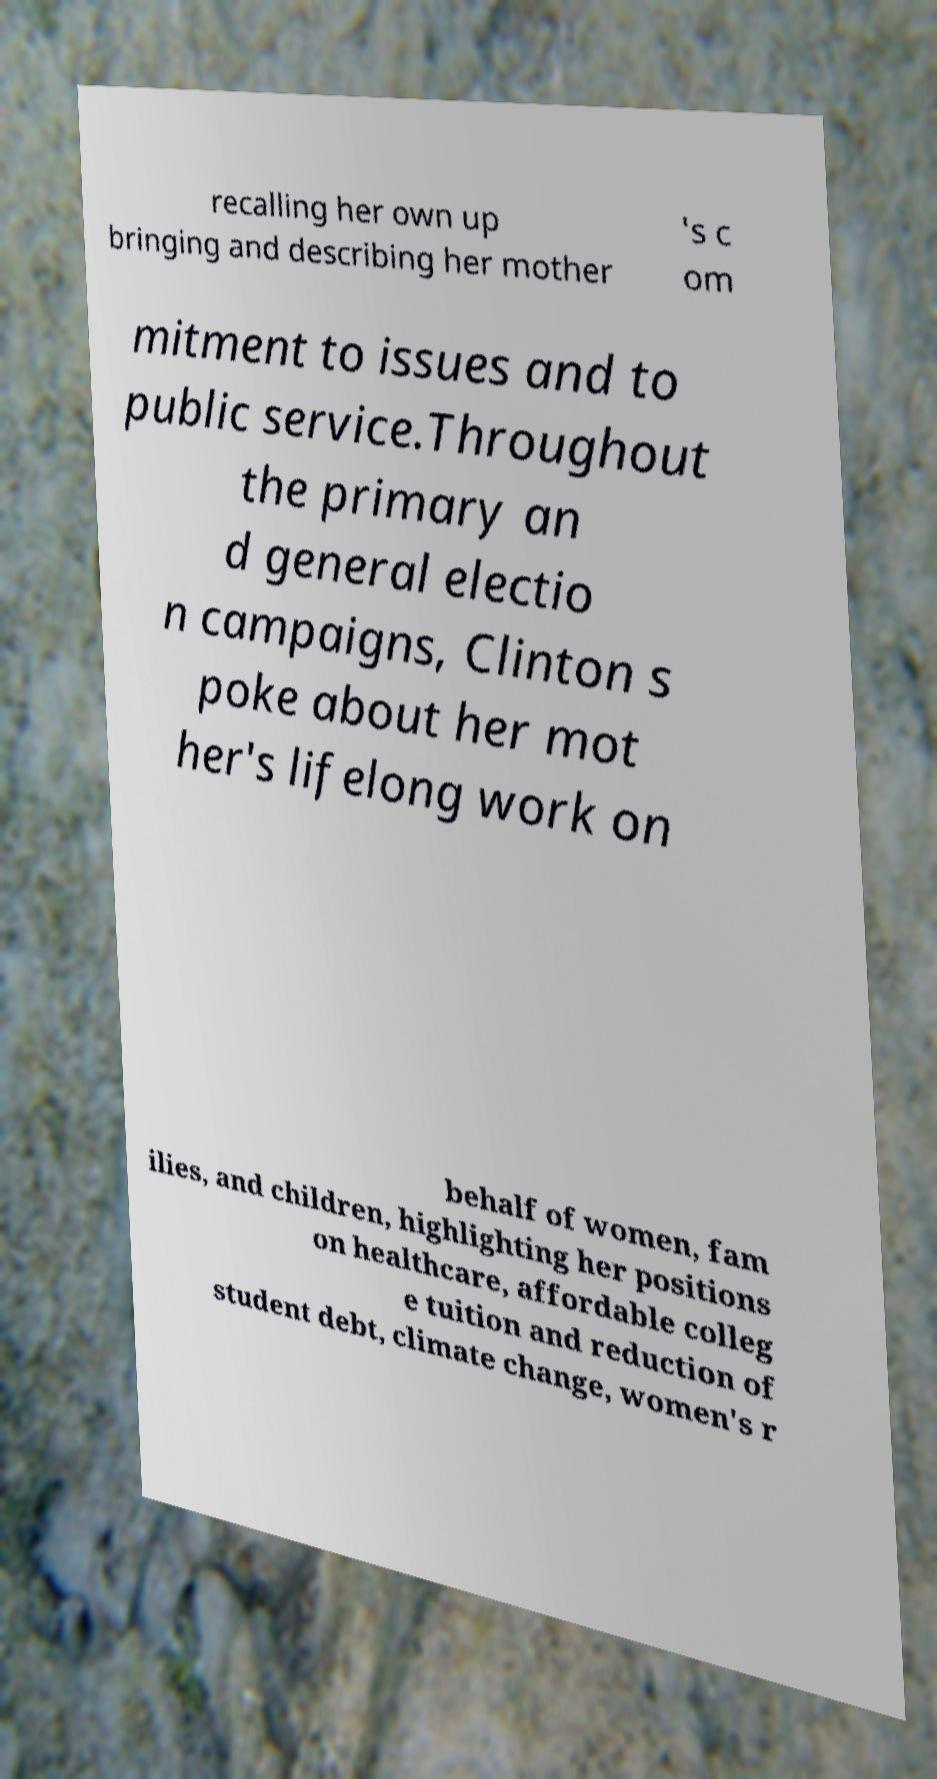Can you accurately transcribe the text from the provided image for me? recalling her own up bringing and describing her mother 's c om mitment to issues and to public service.Throughout the primary an d general electio n campaigns, Clinton s poke about her mot her's lifelong work on behalf of women, fam ilies, and children, highlighting her positions on healthcare, affordable colleg e tuition and reduction of student debt, climate change, women's r 